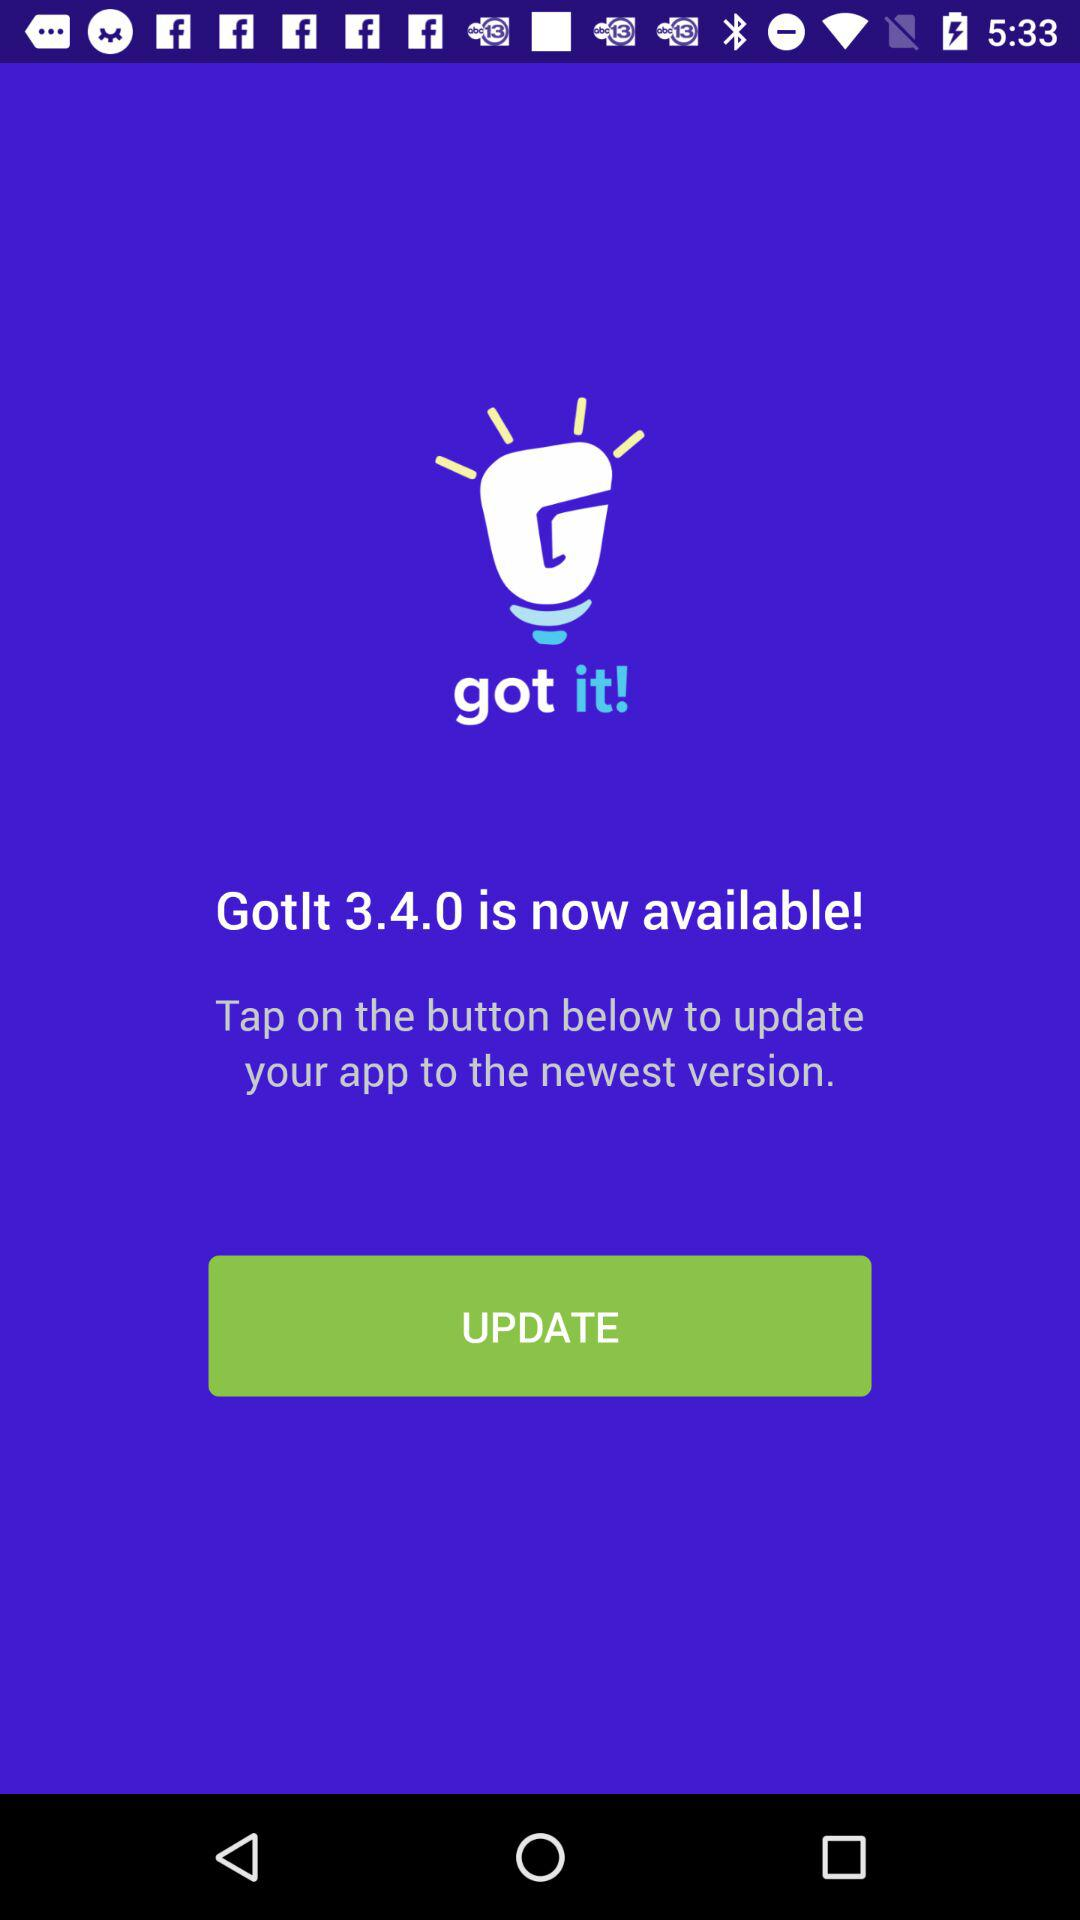What is the name of the application? The name of the application is "got it". 